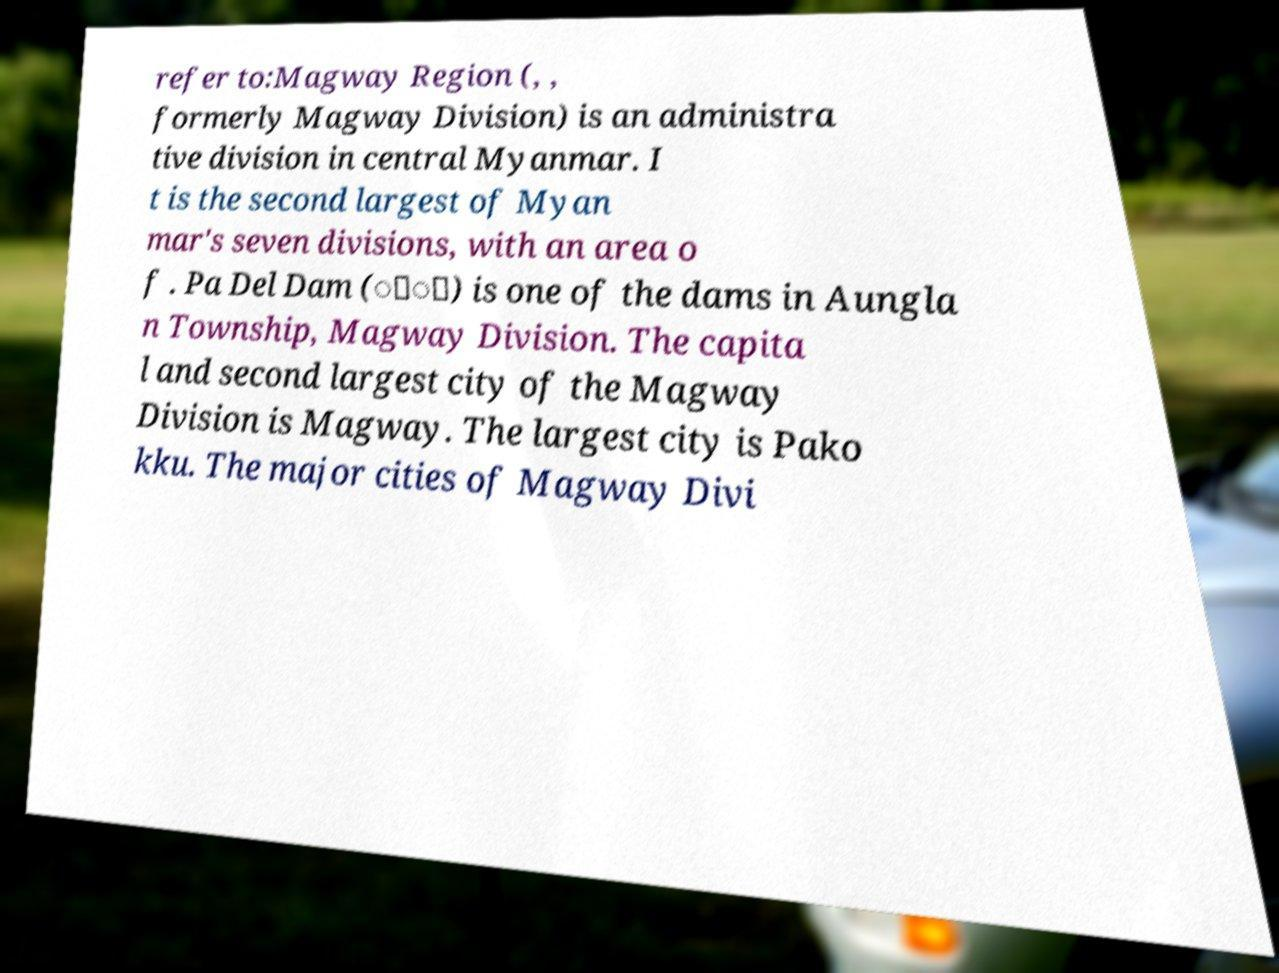Please identify and transcribe the text found in this image. refer to:Magway Region (, , formerly Magway Division) is an administra tive division in central Myanmar. I t is the second largest of Myan mar's seven divisions, with an area o f . Pa Del Dam (ဲ်) is one of the dams in Aungla n Township, Magway Division. The capita l and second largest city of the Magway Division is Magway. The largest city is Pako kku. The major cities of Magway Divi 